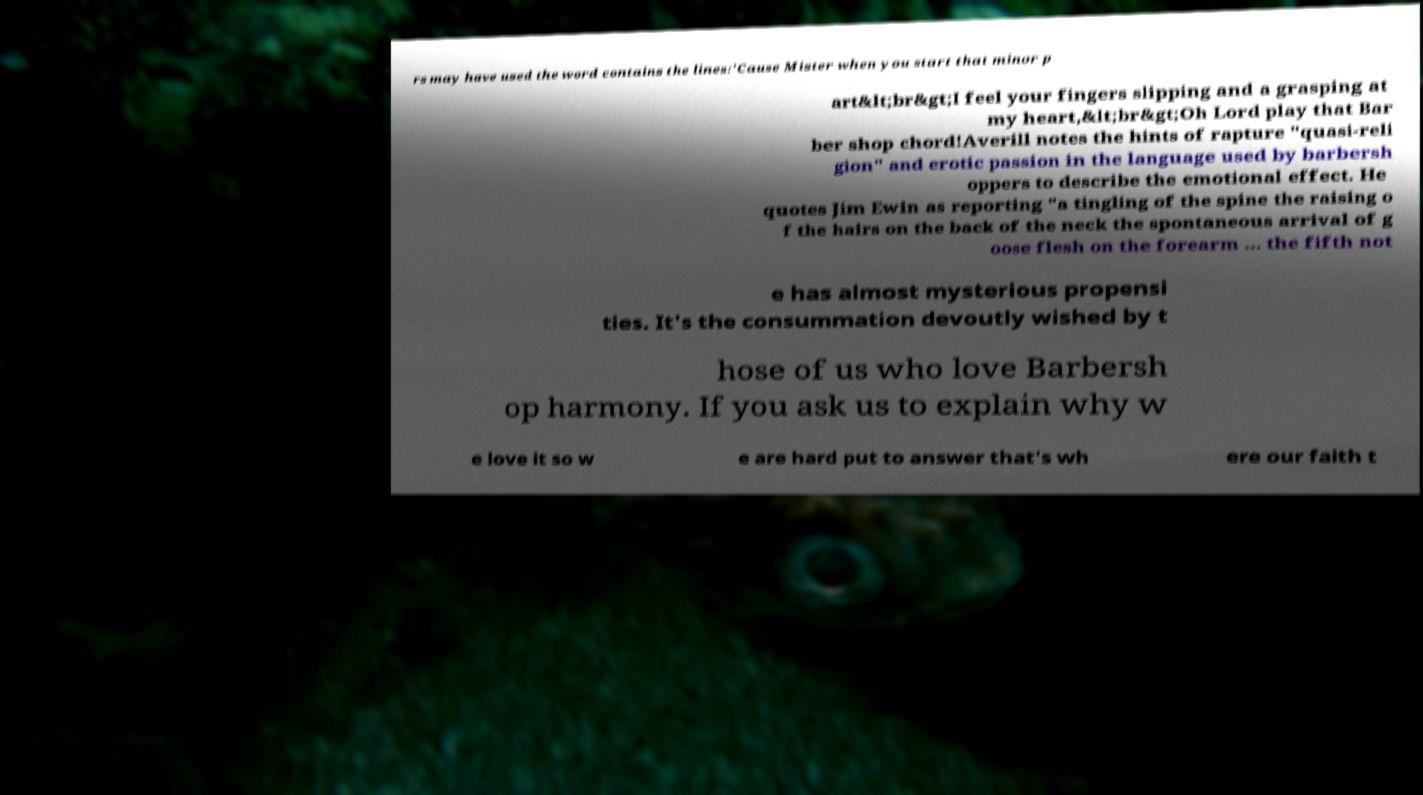Can you read and provide the text displayed in the image?This photo seems to have some interesting text. Can you extract and type it out for me? rs may have used the word contains the lines:'Cause Mister when you start that minor p art&lt;br&gt;I feel your fingers slipping and a grasping at my heart,&lt;br&gt;Oh Lord play that Bar ber shop chord!Averill notes the hints of rapture "quasi-reli gion" and erotic passion in the language used by barbersh oppers to describe the emotional effect. He quotes Jim Ewin as reporting "a tingling of the spine the raising o f the hairs on the back of the neck the spontaneous arrival of g oose flesh on the forearm ... the fifth not e has almost mysterious propensi ties. It's the consummation devoutly wished by t hose of us who love Barbersh op harmony. If you ask us to explain why w e love it so w e are hard put to answer that's wh ere our faith t 